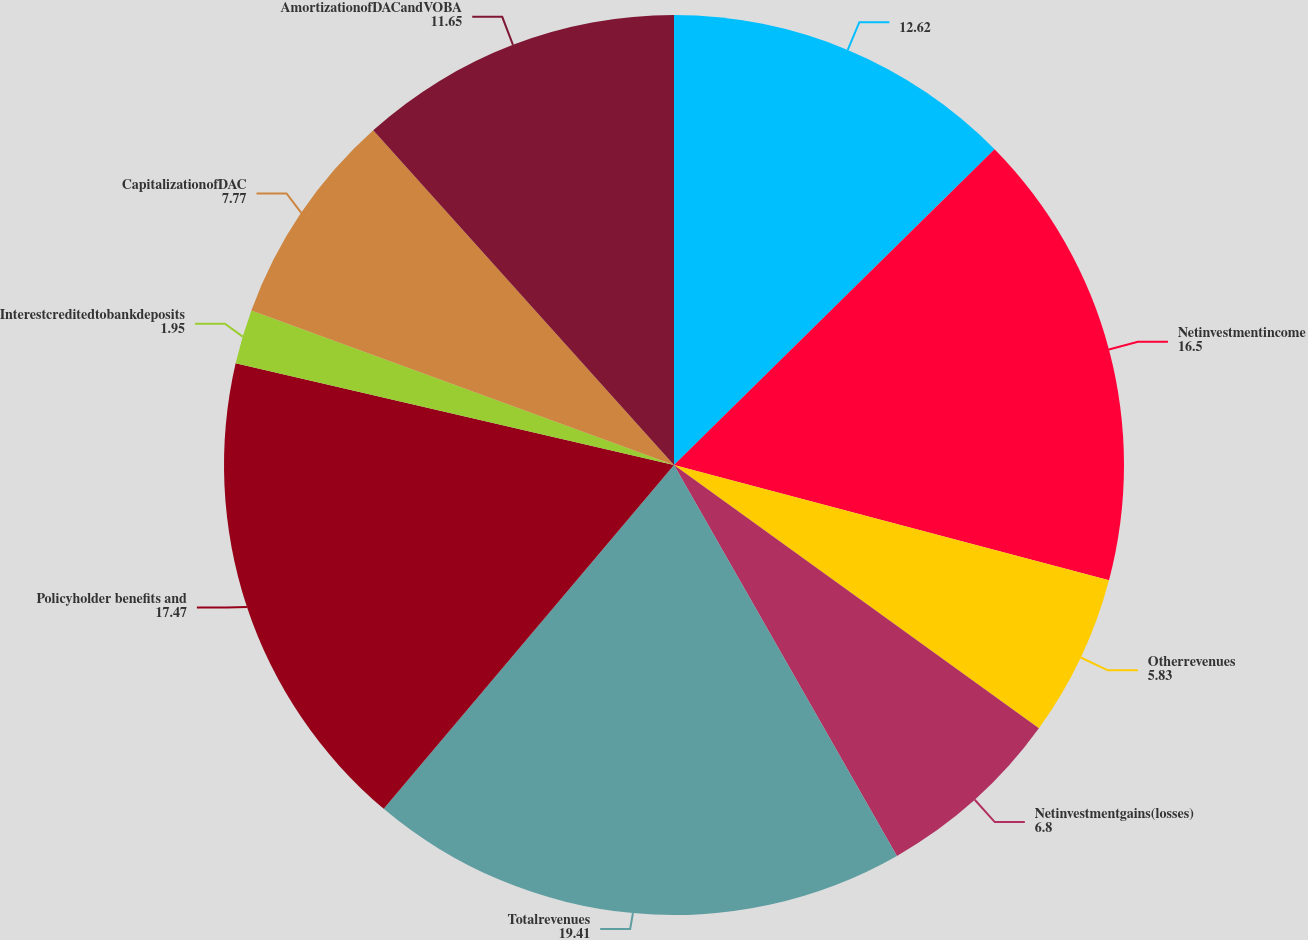Convert chart to OTSL. <chart><loc_0><loc_0><loc_500><loc_500><pie_chart><ecel><fcel>Netinvestmentincome<fcel>Otherrevenues<fcel>Netinvestmentgains(losses)<fcel>Totalrevenues<fcel>Policyholder benefits and<fcel>Interestcreditedtobankdeposits<fcel>CapitalizationofDAC<fcel>AmortizationofDACandVOBA<nl><fcel>12.62%<fcel>16.5%<fcel>5.83%<fcel>6.8%<fcel>19.41%<fcel>17.47%<fcel>1.95%<fcel>7.77%<fcel>11.65%<nl></chart> 